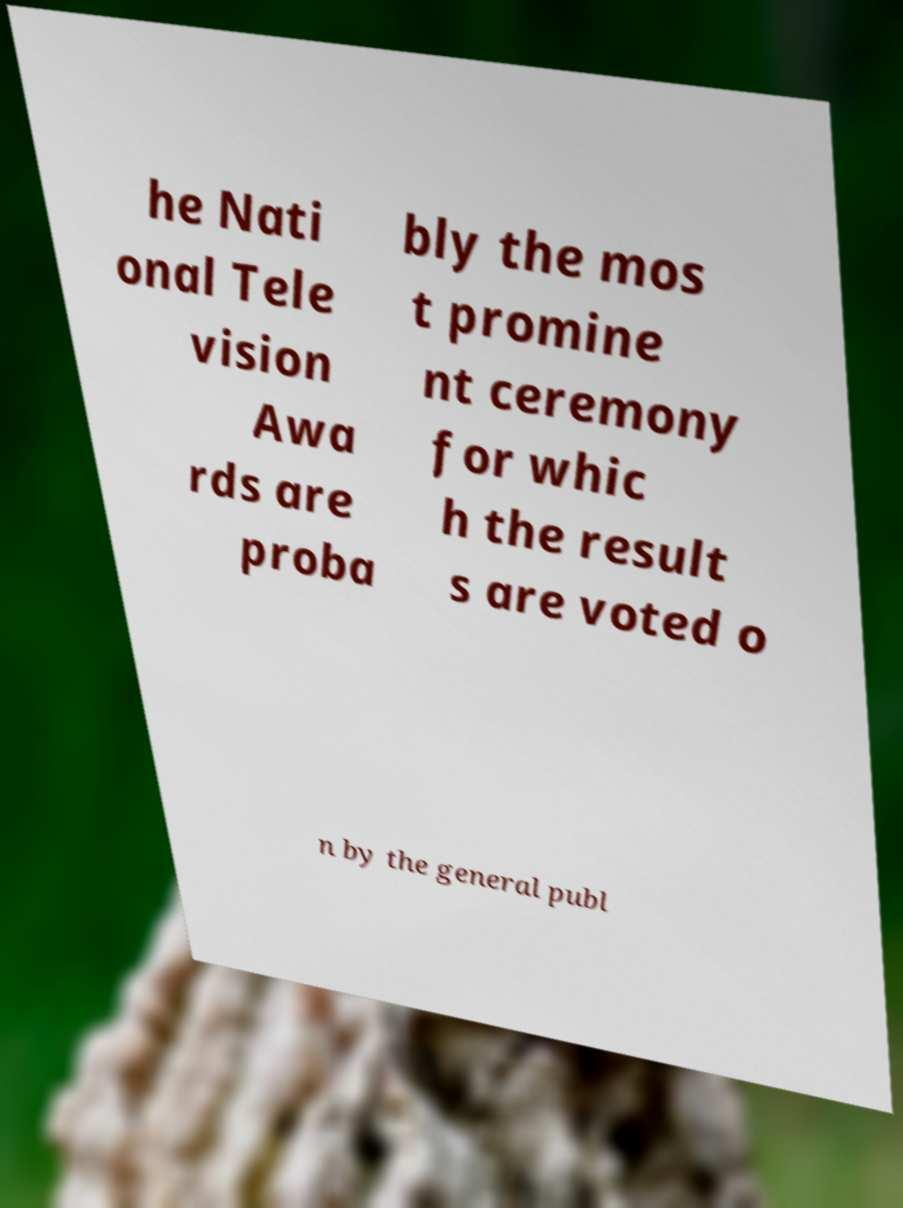What messages or text are displayed in this image? I need them in a readable, typed format. he Nati onal Tele vision Awa rds are proba bly the mos t promine nt ceremony for whic h the result s are voted o n by the general publ 